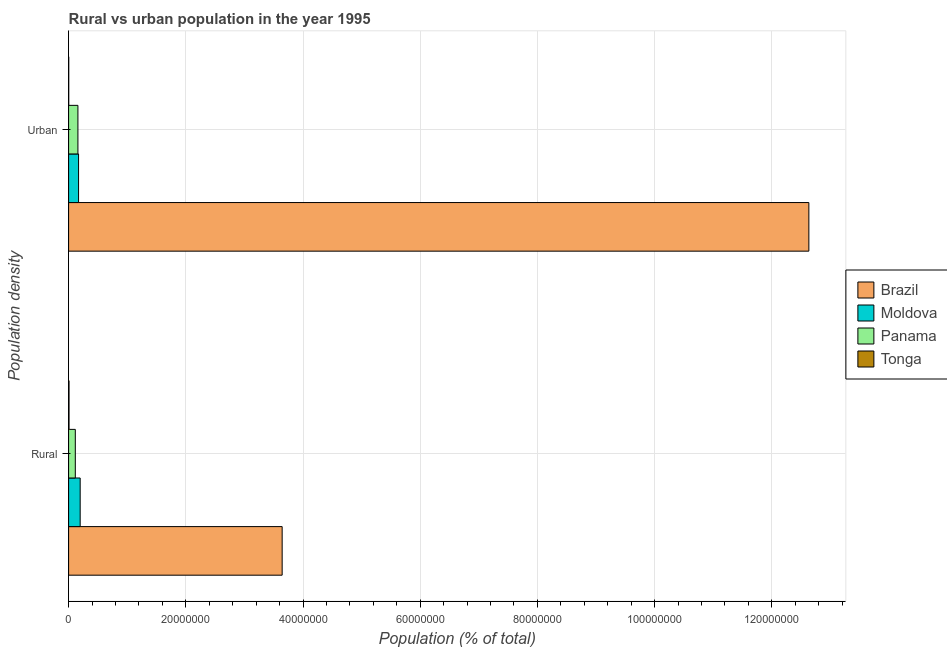How many different coloured bars are there?
Offer a terse response. 4. How many groups of bars are there?
Your response must be concise. 2. How many bars are there on the 2nd tick from the top?
Give a very brief answer. 4. How many bars are there on the 2nd tick from the bottom?
Offer a very short reply. 4. What is the label of the 2nd group of bars from the top?
Provide a succinct answer. Rural. What is the rural population density in Moldova?
Keep it short and to the point. 1.97e+06. Across all countries, what is the maximum urban population density?
Your answer should be very brief. 1.26e+08. Across all countries, what is the minimum urban population density?
Ensure brevity in your answer.  2.19e+04. In which country was the urban population density maximum?
Offer a terse response. Brazil. In which country was the rural population density minimum?
Make the answer very short. Tonga. What is the total urban population density in the graph?
Make the answer very short. 1.30e+08. What is the difference between the rural population density in Moldova and that in Panama?
Provide a short and direct response. 8.28e+05. What is the difference between the rural population density in Moldova and the urban population density in Brazil?
Make the answer very short. -1.24e+08. What is the average rural population density per country?
Your response must be concise. 9.91e+06. What is the difference between the urban population density and rural population density in Panama?
Your answer should be compact. 4.46e+05. What is the ratio of the urban population density in Panama to that in Moldova?
Your answer should be compact. 0.94. Is the urban population density in Panama less than that in Moldova?
Make the answer very short. Yes. What does the 1st bar from the top in Urban represents?
Ensure brevity in your answer.  Tonga. How many countries are there in the graph?
Ensure brevity in your answer.  4. Are the values on the major ticks of X-axis written in scientific E-notation?
Your answer should be very brief. No. Does the graph contain grids?
Provide a short and direct response. Yes. How many legend labels are there?
Offer a terse response. 4. What is the title of the graph?
Make the answer very short. Rural vs urban population in the year 1995. What is the label or title of the X-axis?
Your response must be concise. Population (% of total). What is the label or title of the Y-axis?
Give a very brief answer. Population density. What is the Population (% of total) of Brazil in Rural?
Your answer should be very brief. 3.64e+07. What is the Population (% of total) in Moldova in Rural?
Your answer should be very brief. 1.97e+06. What is the Population (% of total) in Panama in Rural?
Provide a short and direct response. 1.15e+06. What is the Population (% of total) of Tonga in Rural?
Offer a terse response. 7.40e+04. What is the Population (% of total) of Brazil in Urban?
Provide a short and direct response. 1.26e+08. What is the Population (% of total) of Moldova in Urban?
Give a very brief answer. 1.70e+06. What is the Population (% of total) of Panama in Urban?
Your response must be concise. 1.59e+06. What is the Population (% of total) of Tonga in Urban?
Your answer should be very brief. 2.19e+04. Across all Population density, what is the maximum Population (% of total) in Brazil?
Provide a succinct answer. 1.26e+08. Across all Population density, what is the maximum Population (% of total) in Moldova?
Provide a succinct answer. 1.97e+06. Across all Population density, what is the maximum Population (% of total) in Panama?
Your answer should be compact. 1.59e+06. Across all Population density, what is the maximum Population (% of total) of Tonga?
Give a very brief answer. 7.40e+04. Across all Population density, what is the minimum Population (% of total) in Brazil?
Give a very brief answer. 3.64e+07. Across all Population density, what is the minimum Population (% of total) in Moldova?
Make the answer very short. 1.70e+06. Across all Population density, what is the minimum Population (% of total) in Panama?
Keep it short and to the point. 1.15e+06. Across all Population density, what is the minimum Population (% of total) of Tonga?
Provide a short and direct response. 2.19e+04. What is the total Population (% of total) in Brazil in the graph?
Keep it short and to the point. 1.63e+08. What is the total Population (% of total) of Moldova in the graph?
Ensure brevity in your answer.  3.68e+06. What is the total Population (% of total) in Panama in the graph?
Offer a very short reply. 2.74e+06. What is the total Population (% of total) in Tonga in the graph?
Make the answer very short. 9.59e+04. What is the difference between the Population (% of total) of Brazil in Rural and that in Urban?
Provide a succinct answer. -8.99e+07. What is the difference between the Population (% of total) of Moldova in Rural and that in Urban?
Offer a terse response. 2.72e+05. What is the difference between the Population (% of total) in Panama in Rural and that in Urban?
Your answer should be compact. -4.46e+05. What is the difference between the Population (% of total) in Tonga in Rural and that in Urban?
Your answer should be very brief. 5.20e+04. What is the difference between the Population (% of total) in Brazil in Rural and the Population (% of total) in Moldova in Urban?
Provide a succinct answer. 3.47e+07. What is the difference between the Population (% of total) of Brazil in Rural and the Population (% of total) of Panama in Urban?
Provide a succinct answer. 3.48e+07. What is the difference between the Population (% of total) in Brazil in Rural and the Population (% of total) in Tonga in Urban?
Your answer should be very brief. 3.64e+07. What is the difference between the Population (% of total) in Moldova in Rural and the Population (% of total) in Panama in Urban?
Keep it short and to the point. 3.82e+05. What is the difference between the Population (% of total) in Moldova in Rural and the Population (% of total) in Tonga in Urban?
Offer a terse response. 1.95e+06. What is the difference between the Population (% of total) of Panama in Rural and the Population (% of total) of Tonga in Urban?
Offer a very short reply. 1.12e+06. What is the average Population (% of total) of Brazil per Population density?
Provide a short and direct response. 8.14e+07. What is the average Population (% of total) of Moldova per Population density?
Offer a very short reply. 1.84e+06. What is the average Population (% of total) of Panama per Population density?
Keep it short and to the point. 1.37e+06. What is the average Population (% of total) in Tonga per Population density?
Provide a succinct answer. 4.79e+04. What is the difference between the Population (% of total) of Brazil and Population (% of total) of Moldova in Rural?
Offer a very short reply. 3.45e+07. What is the difference between the Population (% of total) in Brazil and Population (% of total) in Panama in Rural?
Provide a short and direct response. 3.53e+07. What is the difference between the Population (% of total) of Brazil and Population (% of total) of Tonga in Rural?
Ensure brevity in your answer.  3.64e+07. What is the difference between the Population (% of total) in Moldova and Population (% of total) in Panama in Rural?
Give a very brief answer. 8.28e+05. What is the difference between the Population (% of total) in Moldova and Population (% of total) in Tonga in Rural?
Make the answer very short. 1.90e+06. What is the difference between the Population (% of total) of Panama and Population (% of total) of Tonga in Rural?
Your answer should be very brief. 1.07e+06. What is the difference between the Population (% of total) of Brazil and Population (% of total) of Moldova in Urban?
Make the answer very short. 1.25e+08. What is the difference between the Population (% of total) of Brazil and Population (% of total) of Panama in Urban?
Give a very brief answer. 1.25e+08. What is the difference between the Population (% of total) of Brazil and Population (% of total) of Tonga in Urban?
Provide a short and direct response. 1.26e+08. What is the difference between the Population (% of total) in Moldova and Population (% of total) in Panama in Urban?
Offer a very short reply. 1.09e+05. What is the difference between the Population (% of total) of Moldova and Population (% of total) of Tonga in Urban?
Your answer should be compact. 1.68e+06. What is the difference between the Population (% of total) of Panama and Population (% of total) of Tonga in Urban?
Give a very brief answer. 1.57e+06. What is the ratio of the Population (% of total) of Brazil in Rural to that in Urban?
Offer a terse response. 0.29. What is the ratio of the Population (% of total) of Moldova in Rural to that in Urban?
Ensure brevity in your answer.  1.16. What is the ratio of the Population (% of total) in Panama in Rural to that in Urban?
Offer a very short reply. 0.72. What is the ratio of the Population (% of total) in Tonga in Rural to that in Urban?
Your answer should be compact. 3.37. What is the difference between the highest and the second highest Population (% of total) in Brazil?
Offer a terse response. 8.99e+07. What is the difference between the highest and the second highest Population (% of total) of Moldova?
Offer a very short reply. 2.72e+05. What is the difference between the highest and the second highest Population (% of total) of Panama?
Offer a terse response. 4.46e+05. What is the difference between the highest and the second highest Population (% of total) in Tonga?
Provide a succinct answer. 5.20e+04. What is the difference between the highest and the lowest Population (% of total) of Brazil?
Provide a short and direct response. 8.99e+07. What is the difference between the highest and the lowest Population (% of total) of Moldova?
Your answer should be very brief. 2.72e+05. What is the difference between the highest and the lowest Population (% of total) in Panama?
Keep it short and to the point. 4.46e+05. What is the difference between the highest and the lowest Population (% of total) in Tonga?
Provide a short and direct response. 5.20e+04. 